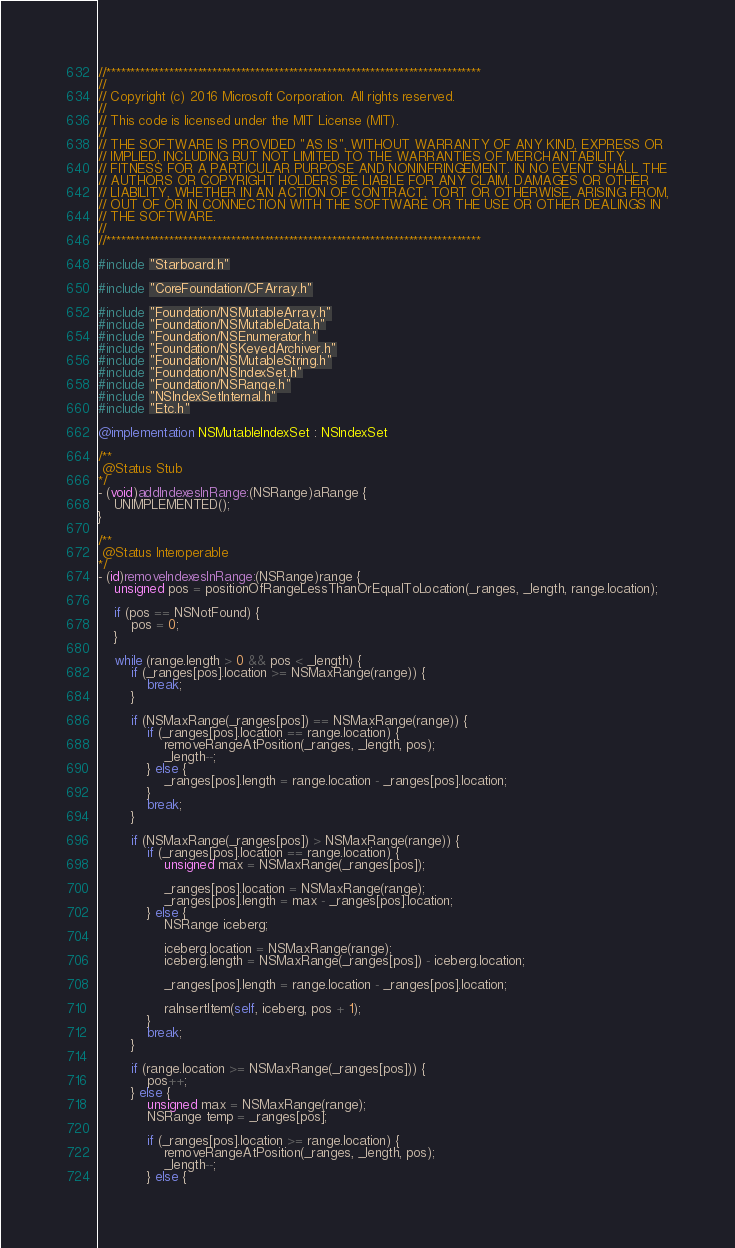<code> <loc_0><loc_0><loc_500><loc_500><_ObjectiveC_>//******************************************************************************
//
// Copyright (c) 2016 Microsoft Corporation. All rights reserved.
//
// This code is licensed under the MIT License (MIT).
//
// THE SOFTWARE IS PROVIDED "AS IS", WITHOUT WARRANTY OF ANY KIND, EXPRESS OR
// IMPLIED, INCLUDING BUT NOT LIMITED TO THE WARRANTIES OF MERCHANTABILITY,
// FITNESS FOR A PARTICULAR PURPOSE AND NONINFRINGEMENT. IN NO EVENT SHALL THE
// AUTHORS OR COPYRIGHT HOLDERS BE LIABLE FOR ANY CLAIM, DAMAGES OR OTHER
// LIABILITY, WHETHER IN AN ACTION OF CONTRACT, TORT OR OTHERWISE, ARISING FROM,
// OUT OF OR IN CONNECTION WITH THE SOFTWARE OR THE USE OR OTHER DEALINGS IN
// THE SOFTWARE.
//
//******************************************************************************

#include "Starboard.h"

#include "CoreFoundation/CFArray.h"

#include "Foundation/NSMutableArray.h"
#include "Foundation/NSMutableData.h"
#include "Foundation/NSEnumerator.h"
#include "Foundation/NSKeyedArchiver.h"
#include "Foundation/NSMutableString.h"
#include "Foundation/NSIndexSet.h"
#include "Foundation/NSRange.h"
#include "NSIndexSetInternal.h"
#include "Etc.h"

@implementation NSMutableIndexSet : NSIndexSet

/**
 @Status Stub
*/
- (void)addIndexesInRange:(NSRange)aRange {
    UNIMPLEMENTED();
}

/**
 @Status Interoperable
*/
- (id)removeIndexesInRange:(NSRange)range {
    unsigned pos = positionOfRangeLessThanOrEqualToLocation(_ranges, _length, range.location);

    if (pos == NSNotFound) {
        pos = 0;
    }

    while (range.length > 0 && pos < _length) {
        if (_ranges[pos].location >= NSMaxRange(range)) {
            break;
        }

        if (NSMaxRange(_ranges[pos]) == NSMaxRange(range)) {
            if (_ranges[pos].location == range.location) {
                removeRangeAtPosition(_ranges, _length, pos);
                _length--;
            } else {
                _ranges[pos].length = range.location - _ranges[pos].location;
            }
            break;
        }

        if (NSMaxRange(_ranges[pos]) > NSMaxRange(range)) {
            if (_ranges[pos].location == range.location) {
                unsigned max = NSMaxRange(_ranges[pos]);

                _ranges[pos].location = NSMaxRange(range);
                _ranges[pos].length = max - _ranges[pos].location;
            } else {
                NSRange iceberg;

                iceberg.location = NSMaxRange(range);
                iceberg.length = NSMaxRange(_ranges[pos]) - iceberg.location;

                _ranges[pos].length = range.location - _ranges[pos].location;

                raInsertItem(self, iceberg, pos + 1);
            }
            break;
        }

        if (range.location >= NSMaxRange(_ranges[pos])) {
            pos++;
        } else {
            unsigned max = NSMaxRange(range);
            NSRange temp = _ranges[pos];

            if (_ranges[pos].location >= range.location) {
                removeRangeAtPosition(_ranges, _length, pos);
                _length--;
            } else {</code> 